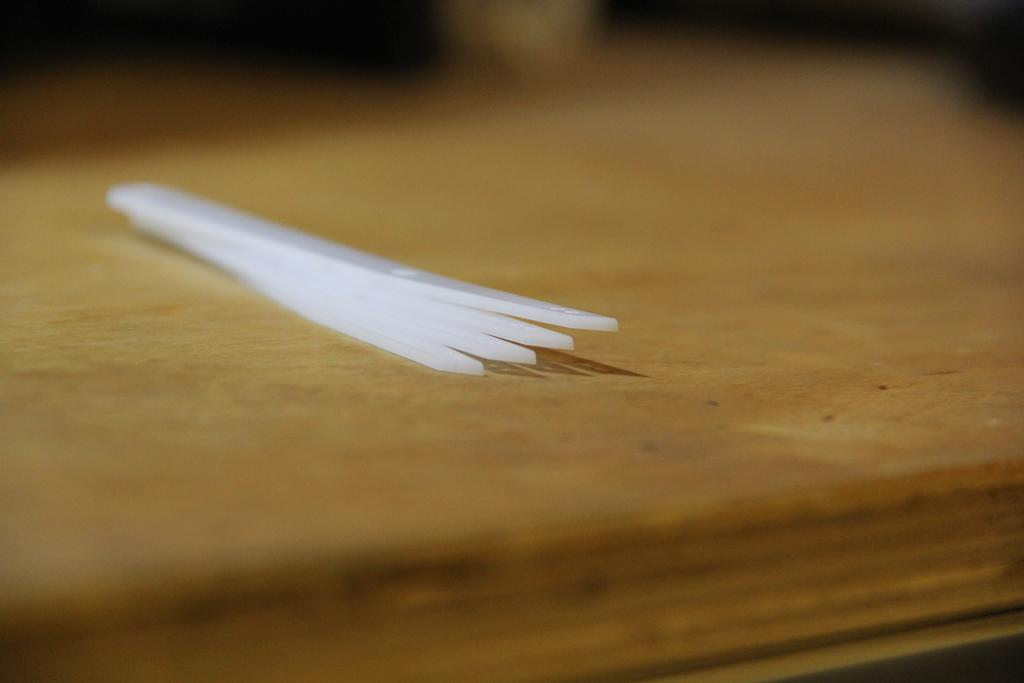What type of surface can be seen supporting objects in the image? There is a wooden table in the image. Can you describe the objects on the wooden table? Unfortunately, the provided facts do not specify the objects on the table. What grade did the person receive for their joke in the image? There is no person, joke, or grade present in the image. 